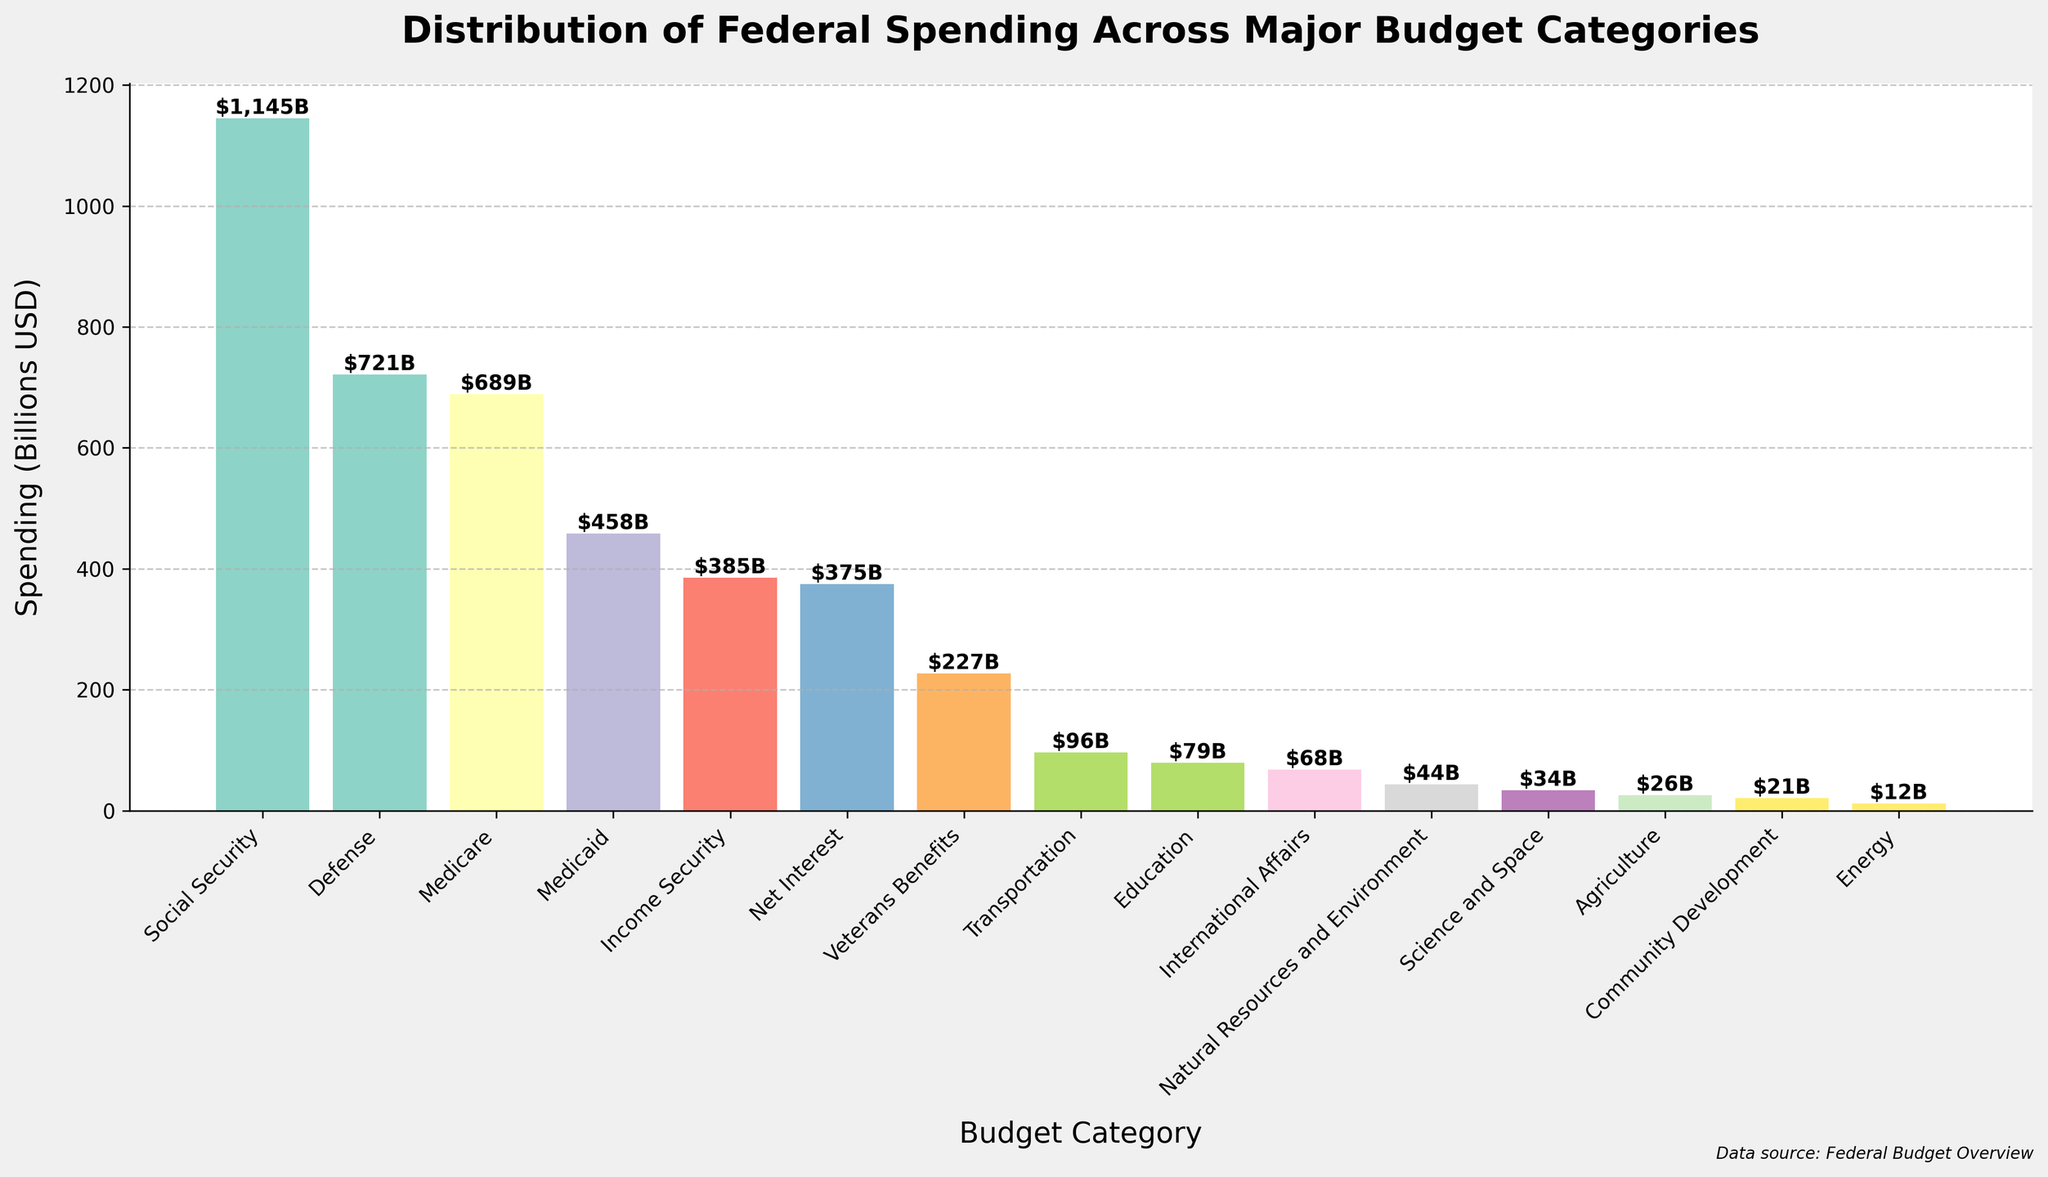What is the total spending on Social Security and Medicare combined? To find the combined spending for Social Security and Medicare, add the spending amounts for both categories: $1145 billion (Social Security) + $689 billion (Medicare).
Answer: $1834 billion Which category has a higher spending: Defense or Medicare? Compare the spending amounts for Defense ($721 billion) and Medicare ($689 billion). Defense has a higher spending.
Answer: Defense What is the difference in spending between Medicaid and Income Security? Subtract the spending of Income Security ($385 billion) from the spending of Medicaid ($458 billion): $458 billion - $385 billion.
Answer: $73 billion How many categories have spending greater than $500 billion? Identify the categories with spending amounts greater than $500 billion: Social Security ($1145 billion) and Defense ($721 billion). There are three categories.
Answer: 3 Which category has the lowest spending, and what is its amount? Look at the bars to find the shortest one, which represents the lowest spending amount. The Agriculture category has the lowest spending at $26 billion.
Answer: Agriculture, $26 billion How does the spending on Veterans Benefits compare to spending on Education? Compare the spending between Veterans Benefits ($227 billion) and Education ($79 billion). Veterans Benefits has higher spending than Education.
Answer: Veterans Benefits Among Natural Resources and Environment, Community Development, and Agriculture, which has the smallest spending and what is the amount? Compare the spending amounts of Natural Resources and Environment ($44 billion), Community Development ($21 billion), and Agriculture ($26 billion). Community Development has the smallest spending.
Answer: Community Development, $21 billion What is the average spending across all given categories? Calculate the sum of all spending amounts and divide by the number of categories: (721 + 1145 + 689 + 458 + 385 + 375 + 227 + 79 + 96 + 68 + 34 + 26 + 12 + 21 + 44) / 15 = 4380 / 15.
Answer: $292 billion Which category has the second highest spending, and what is its amount? Identify the category with the top spending (Social Security, $1145 billion), and then the next highest category (Defense, $721 billion).
Answer: Defense, $721 billion Is the spending on Transportation greater than or equal to the combined spending on International Affairs and Science and Space? Add the spending amounts for International Affairs ($68 billion) and Science and Space ($34 billion), then compare the sum to Transportation's spending ($96 billion): $68 billion + $34 billion = $102 billion, which is greater than $96 billion.
Answer: No 